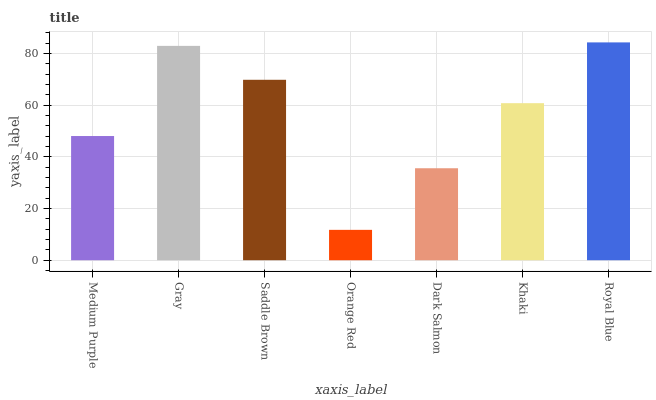Is Orange Red the minimum?
Answer yes or no. Yes. Is Royal Blue the maximum?
Answer yes or no. Yes. Is Gray the minimum?
Answer yes or no. No. Is Gray the maximum?
Answer yes or no. No. Is Gray greater than Medium Purple?
Answer yes or no. Yes. Is Medium Purple less than Gray?
Answer yes or no. Yes. Is Medium Purple greater than Gray?
Answer yes or no. No. Is Gray less than Medium Purple?
Answer yes or no. No. Is Khaki the high median?
Answer yes or no. Yes. Is Khaki the low median?
Answer yes or no. Yes. Is Medium Purple the high median?
Answer yes or no. No. Is Dark Salmon the low median?
Answer yes or no. No. 